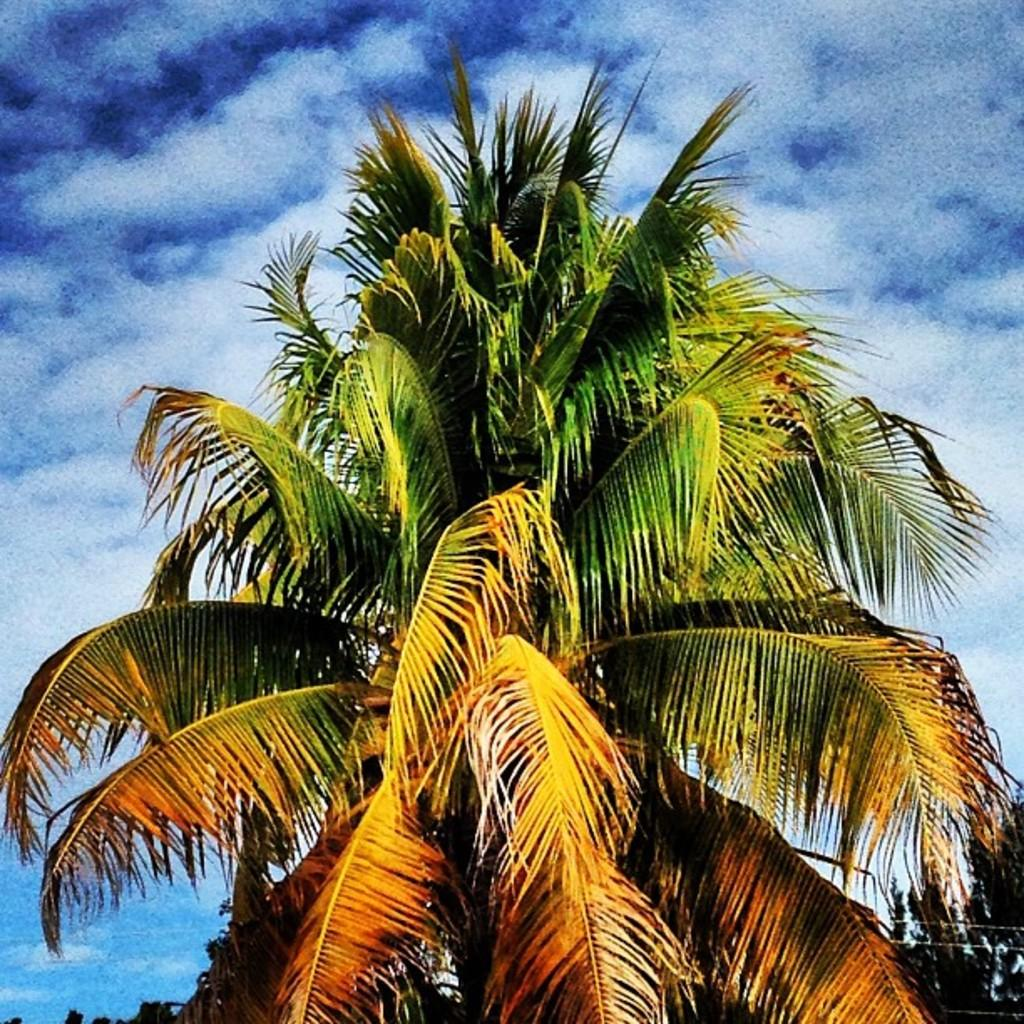What type of tree is in the picture? There is a coconut tree in the picture. How many leaves does the coconut tree have? The coconut tree has many leaves. What can be seen in the background of the picture? There is a sky visible in the picture. What is present in the sky? Clouds are present in the sky. What type of ink is being used to write on the coconut tree? There is no ink or writing present on the coconut tree in the image. Can you hear the voice of the coconut tree in the image? Coconut trees do not have voices, and there is no sound present in the image. 